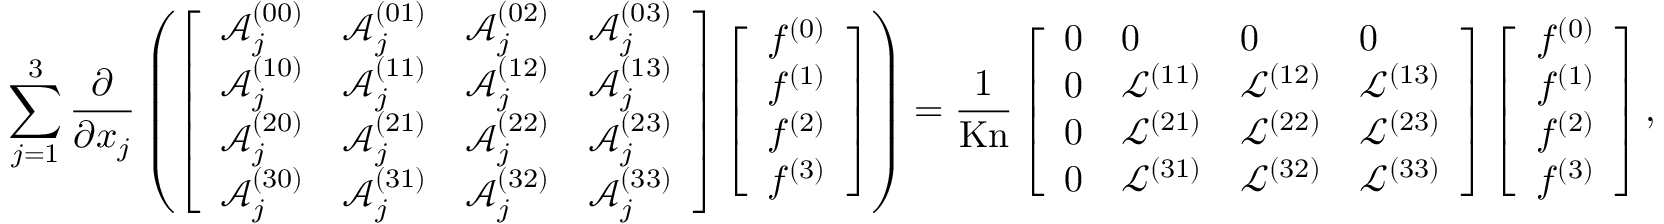Convert formula to latex. <formula><loc_0><loc_0><loc_500><loc_500>\sum _ { j = 1 } ^ { 3 } \frac { \partial } { \partial x _ { j } } \left ( \left [ \begin{array} { l l l l } { \mathcal { A } _ { j } ^ { ( 0 0 ) } } & { \mathcal { A } _ { j } ^ { ( 0 1 ) } } & { \mathcal { A } _ { j } ^ { ( 0 2 ) } } & { \mathcal { A } _ { j } ^ { ( 0 3 ) } } \\ { \mathcal { A } _ { j } ^ { ( 1 0 ) } } & { \mathcal { A } _ { j } ^ { ( 1 1 ) } } & { \mathcal { A } _ { j } ^ { ( 1 2 ) } } & { \mathcal { A } _ { j } ^ { ( 1 3 ) } } \\ { \mathcal { A } _ { j } ^ { ( 2 0 ) } } & { \mathcal { A } _ { j } ^ { ( 2 1 ) } } & { \mathcal { A } _ { j } ^ { ( 2 2 ) } } & { \mathcal { A } _ { j } ^ { ( 2 3 ) } } \\ { \mathcal { A } _ { j } ^ { ( 3 0 ) } } & { \mathcal { A } _ { j } ^ { ( 3 1 ) } } & { \mathcal { A } _ { j } ^ { ( 3 2 ) } } & { \mathcal { A } _ { j } ^ { ( 3 3 ) } } \end{array} \right ] \left [ \begin{array} { l } { f ^ { ( 0 ) } } \\ { f ^ { ( 1 ) } } \\ { f ^ { ( 2 ) } } \\ { f ^ { ( 3 ) } } \end{array} \right ] \right ) = \frac { 1 } { K n } \left [ \begin{array} { l l l l } { 0 } & { 0 } & { 0 } & { 0 } \\ { 0 } & { \mathcal { L } ^ { ( 1 1 ) } } & { \mathcal { L } ^ { ( 1 2 ) } } & { \mathcal { L } ^ { ( 1 3 ) } } \\ { 0 } & { \mathcal { L } ^ { ( 2 1 ) } } & { \mathcal { L } ^ { ( 2 2 ) } } & { \mathcal { L } ^ { ( 2 3 ) } } \\ { 0 } & { \mathcal { L } ^ { ( 3 1 ) } } & { \mathcal { L } ^ { ( 3 2 ) } } & { \mathcal { L } ^ { ( 3 3 ) } } \end{array} \right ] \left [ \begin{array} { l } { f ^ { ( 0 ) } } \\ { f ^ { ( 1 ) } } \\ { f ^ { ( 2 ) } } \\ { f ^ { ( 3 ) } } \end{array} \right ] ,</formula> 